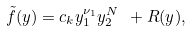Convert formula to latex. <formula><loc_0><loc_0><loc_500><loc_500>\tilde { f } ( y ) = c _ { k } y _ { 1 } ^ { \nu _ { 1 } } y _ { 2 } ^ { N } \ + R ( y ) ,</formula> 